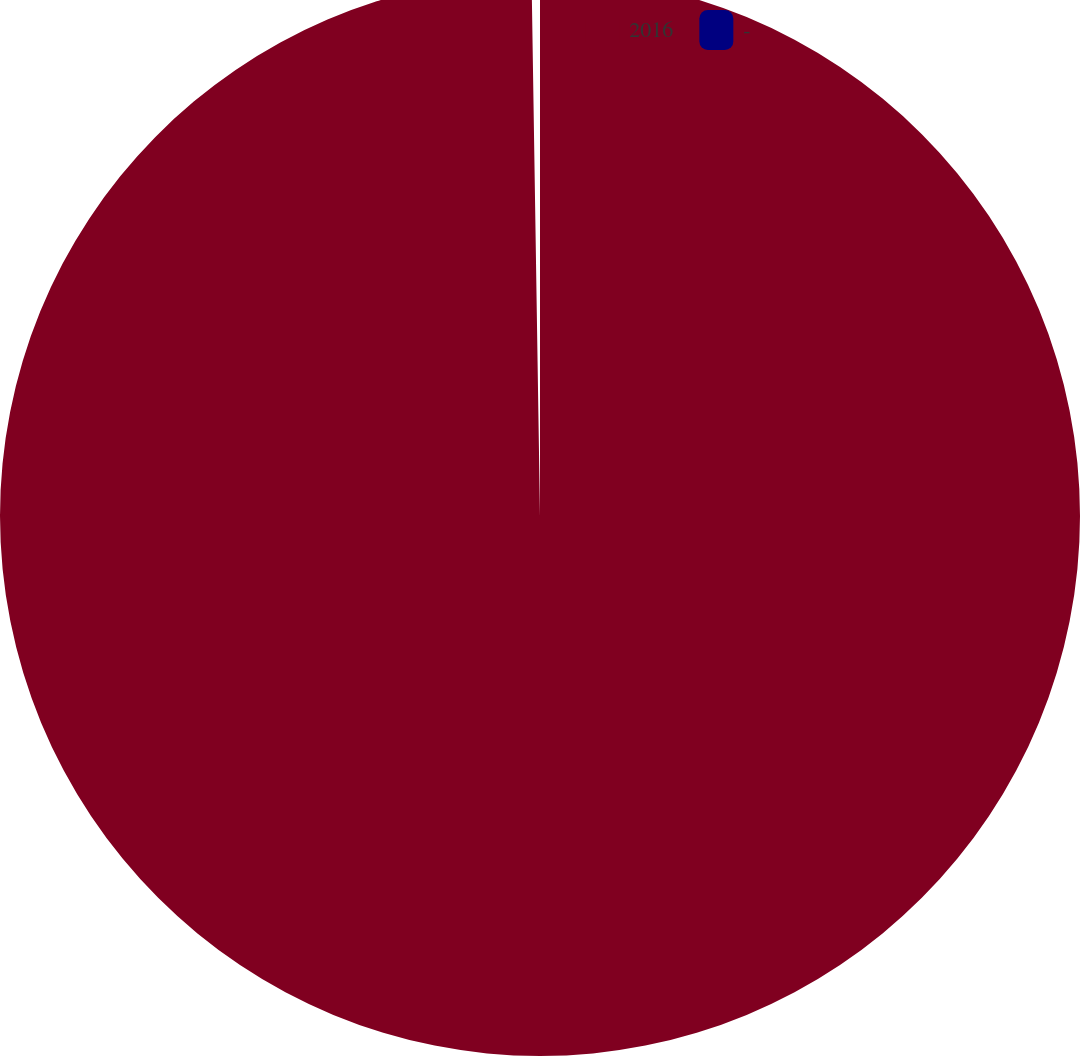<chart> <loc_0><loc_0><loc_500><loc_500><pie_chart><fcel>2016<fcel>-<nl><fcel>99.75%<fcel>0.25%<nl></chart> 